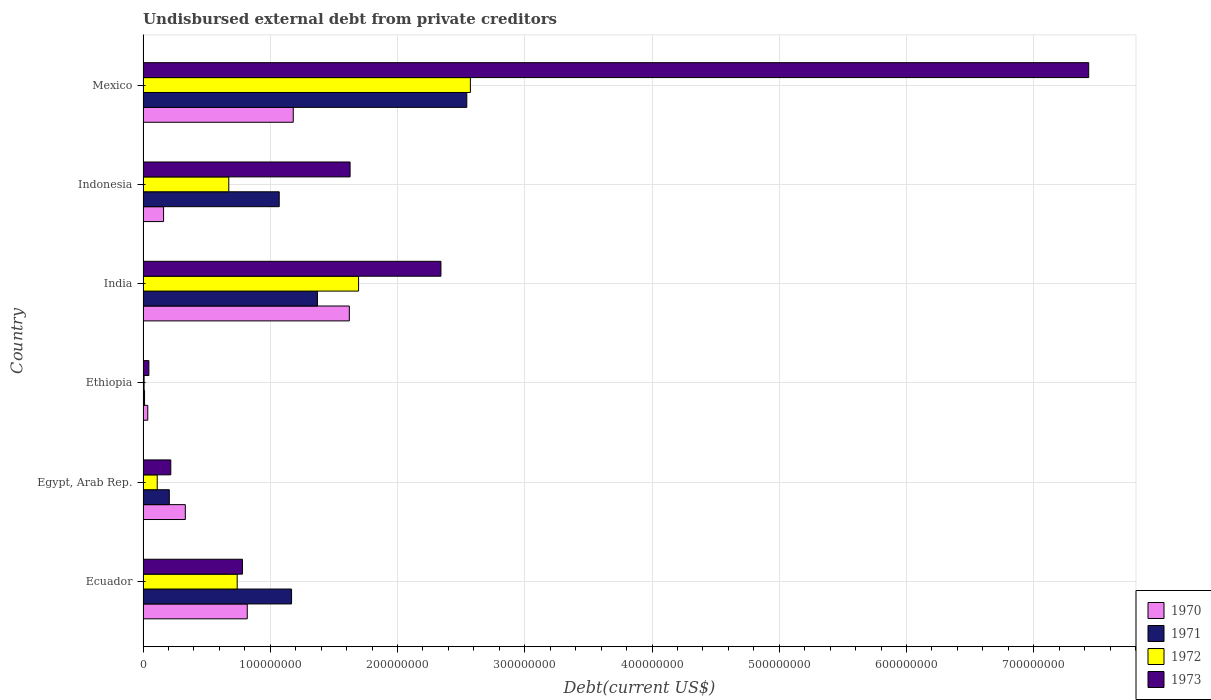How many different coloured bars are there?
Provide a succinct answer. 4. What is the label of the 4th group of bars from the top?
Provide a short and direct response. Ethiopia. In how many cases, is the number of bars for a given country not equal to the number of legend labels?
Your answer should be compact. 0. What is the total debt in 1973 in Ethiopia?
Make the answer very short. 4.57e+06. Across all countries, what is the maximum total debt in 1973?
Give a very brief answer. 7.43e+08. Across all countries, what is the minimum total debt in 1970?
Offer a very short reply. 3.70e+06. In which country was the total debt in 1973 maximum?
Ensure brevity in your answer.  Mexico. In which country was the total debt in 1970 minimum?
Offer a terse response. Ethiopia. What is the total total debt in 1972 in the graph?
Your answer should be very brief. 5.80e+08. What is the difference between the total debt in 1970 in India and that in Mexico?
Give a very brief answer. 4.41e+07. What is the difference between the total debt in 1970 in India and the total debt in 1971 in Ecuador?
Your response must be concise. 4.54e+07. What is the average total debt in 1971 per country?
Your answer should be very brief. 1.06e+08. What is the difference between the total debt in 1972 and total debt in 1973 in Ecuador?
Ensure brevity in your answer.  -4.14e+06. What is the ratio of the total debt in 1973 in India to that in Mexico?
Your answer should be compact. 0.31. Is the total debt in 1971 in India less than that in Indonesia?
Ensure brevity in your answer.  No. Is the difference between the total debt in 1972 in Ecuador and Indonesia greater than the difference between the total debt in 1973 in Ecuador and Indonesia?
Keep it short and to the point. Yes. What is the difference between the highest and the second highest total debt in 1970?
Keep it short and to the point. 4.41e+07. What is the difference between the highest and the lowest total debt in 1970?
Keep it short and to the point. 1.58e+08. Is the sum of the total debt in 1972 in Egypt, Arab Rep. and Ethiopia greater than the maximum total debt in 1973 across all countries?
Provide a short and direct response. No. What does the 1st bar from the top in Egypt, Arab Rep. represents?
Make the answer very short. 1973. Is it the case that in every country, the sum of the total debt in 1971 and total debt in 1972 is greater than the total debt in 1970?
Keep it short and to the point. No. Are all the bars in the graph horizontal?
Your response must be concise. Yes. What is the difference between two consecutive major ticks on the X-axis?
Make the answer very short. 1.00e+08. What is the title of the graph?
Your answer should be compact. Undisbursed external debt from private creditors. What is the label or title of the X-axis?
Provide a succinct answer. Debt(current US$). What is the Debt(current US$) of 1970 in Ecuador?
Your answer should be compact. 8.19e+07. What is the Debt(current US$) of 1971 in Ecuador?
Your answer should be compact. 1.17e+08. What is the Debt(current US$) in 1972 in Ecuador?
Your response must be concise. 7.40e+07. What is the Debt(current US$) of 1973 in Ecuador?
Offer a very short reply. 7.81e+07. What is the Debt(current US$) in 1970 in Egypt, Arab Rep.?
Ensure brevity in your answer.  3.32e+07. What is the Debt(current US$) in 1971 in Egypt, Arab Rep.?
Your response must be concise. 2.06e+07. What is the Debt(current US$) of 1972 in Egypt, Arab Rep.?
Your response must be concise. 1.11e+07. What is the Debt(current US$) of 1973 in Egypt, Arab Rep.?
Give a very brief answer. 2.18e+07. What is the Debt(current US$) in 1970 in Ethiopia?
Provide a succinct answer. 3.70e+06. What is the Debt(current US$) in 1971 in Ethiopia?
Your answer should be very brief. 1.16e+06. What is the Debt(current US$) of 1972 in Ethiopia?
Offer a terse response. 8.20e+05. What is the Debt(current US$) of 1973 in Ethiopia?
Your answer should be compact. 4.57e+06. What is the Debt(current US$) in 1970 in India?
Offer a terse response. 1.62e+08. What is the Debt(current US$) in 1971 in India?
Give a very brief answer. 1.37e+08. What is the Debt(current US$) in 1972 in India?
Your answer should be very brief. 1.69e+08. What is the Debt(current US$) of 1973 in India?
Keep it short and to the point. 2.34e+08. What is the Debt(current US$) of 1970 in Indonesia?
Your answer should be very brief. 1.61e+07. What is the Debt(current US$) of 1971 in Indonesia?
Provide a succinct answer. 1.07e+08. What is the Debt(current US$) of 1972 in Indonesia?
Offer a very short reply. 6.74e+07. What is the Debt(current US$) of 1973 in Indonesia?
Make the answer very short. 1.63e+08. What is the Debt(current US$) in 1970 in Mexico?
Provide a succinct answer. 1.18e+08. What is the Debt(current US$) of 1971 in Mexico?
Your response must be concise. 2.54e+08. What is the Debt(current US$) in 1972 in Mexico?
Your answer should be very brief. 2.57e+08. What is the Debt(current US$) of 1973 in Mexico?
Offer a terse response. 7.43e+08. Across all countries, what is the maximum Debt(current US$) in 1970?
Ensure brevity in your answer.  1.62e+08. Across all countries, what is the maximum Debt(current US$) in 1971?
Keep it short and to the point. 2.54e+08. Across all countries, what is the maximum Debt(current US$) in 1972?
Provide a short and direct response. 2.57e+08. Across all countries, what is the maximum Debt(current US$) of 1973?
Ensure brevity in your answer.  7.43e+08. Across all countries, what is the minimum Debt(current US$) in 1970?
Offer a terse response. 3.70e+06. Across all countries, what is the minimum Debt(current US$) in 1971?
Ensure brevity in your answer.  1.16e+06. Across all countries, what is the minimum Debt(current US$) in 1972?
Provide a succinct answer. 8.20e+05. Across all countries, what is the minimum Debt(current US$) of 1973?
Ensure brevity in your answer.  4.57e+06. What is the total Debt(current US$) of 1970 in the graph?
Provide a short and direct response. 4.15e+08. What is the total Debt(current US$) of 1971 in the graph?
Keep it short and to the point. 6.37e+08. What is the total Debt(current US$) in 1972 in the graph?
Provide a short and direct response. 5.80e+08. What is the total Debt(current US$) in 1973 in the graph?
Your response must be concise. 1.24e+09. What is the difference between the Debt(current US$) of 1970 in Ecuador and that in Egypt, Arab Rep.?
Keep it short and to the point. 4.87e+07. What is the difference between the Debt(current US$) of 1971 in Ecuador and that in Egypt, Arab Rep.?
Keep it short and to the point. 9.61e+07. What is the difference between the Debt(current US$) in 1972 in Ecuador and that in Egypt, Arab Rep.?
Provide a succinct answer. 6.28e+07. What is the difference between the Debt(current US$) of 1973 in Ecuador and that in Egypt, Arab Rep.?
Offer a terse response. 5.63e+07. What is the difference between the Debt(current US$) in 1970 in Ecuador and that in Ethiopia?
Offer a very short reply. 7.82e+07. What is the difference between the Debt(current US$) of 1971 in Ecuador and that in Ethiopia?
Keep it short and to the point. 1.16e+08. What is the difference between the Debt(current US$) of 1972 in Ecuador and that in Ethiopia?
Offer a very short reply. 7.32e+07. What is the difference between the Debt(current US$) in 1973 in Ecuador and that in Ethiopia?
Offer a terse response. 7.35e+07. What is the difference between the Debt(current US$) of 1970 in Ecuador and that in India?
Keep it short and to the point. -8.02e+07. What is the difference between the Debt(current US$) of 1971 in Ecuador and that in India?
Keep it short and to the point. -2.03e+07. What is the difference between the Debt(current US$) of 1972 in Ecuador and that in India?
Your answer should be very brief. -9.54e+07. What is the difference between the Debt(current US$) of 1973 in Ecuador and that in India?
Provide a succinct answer. -1.56e+08. What is the difference between the Debt(current US$) of 1970 in Ecuador and that in Indonesia?
Ensure brevity in your answer.  6.58e+07. What is the difference between the Debt(current US$) in 1971 in Ecuador and that in Indonesia?
Keep it short and to the point. 9.70e+06. What is the difference between the Debt(current US$) in 1972 in Ecuador and that in Indonesia?
Your answer should be compact. 6.60e+06. What is the difference between the Debt(current US$) in 1973 in Ecuador and that in Indonesia?
Your response must be concise. -8.46e+07. What is the difference between the Debt(current US$) of 1970 in Ecuador and that in Mexico?
Offer a terse response. -3.62e+07. What is the difference between the Debt(current US$) of 1971 in Ecuador and that in Mexico?
Offer a terse response. -1.38e+08. What is the difference between the Debt(current US$) in 1972 in Ecuador and that in Mexico?
Your answer should be compact. -1.83e+08. What is the difference between the Debt(current US$) in 1973 in Ecuador and that in Mexico?
Provide a succinct answer. -6.65e+08. What is the difference between the Debt(current US$) in 1970 in Egypt, Arab Rep. and that in Ethiopia?
Give a very brief answer. 2.95e+07. What is the difference between the Debt(current US$) of 1971 in Egypt, Arab Rep. and that in Ethiopia?
Ensure brevity in your answer.  1.95e+07. What is the difference between the Debt(current US$) in 1972 in Egypt, Arab Rep. and that in Ethiopia?
Provide a succinct answer. 1.03e+07. What is the difference between the Debt(current US$) in 1973 in Egypt, Arab Rep. and that in Ethiopia?
Keep it short and to the point. 1.72e+07. What is the difference between the Debt(current US$) of 1970 in Egypt, Arab Rep. and that in India?
Offer a terse response. -1.29e+08. What is the difference between the Debt(current US$) of 1971 in Egypt, Arab Rep. and that in India?
Offer a terse response. -1.16e+08. What is the difference between the Debt(current US$) in 1972 in Egypt, Arab Rep. and that in India?
Offer a terse response. -1.58e+08. What is the difference between the Debt(current US$) in 1973 in Egypt, Arab Rep. and that in India?
Ensure brevity in your answer.  -2.12e+08. What is the difference between the Debt(current US$) in 1970 in Egypt, Arab Rep. and that in Indonesia?
Ensure brevity in your answer.  1.71e+07. What is the difference between the Debt(current US$) of 1971 in Egypt, Arab Rep. and that in Indonesia?
Ensure brevity in your answer.  -8.64e+07. What is the difference between the Debt(current US$) in 1972 in Egypt, Arab Rep. and that in Indonesia?
Ensure brevity in your answer.  -5.62e+07. What is the difference between the Debt(current US$) of 1973 in Egypt, Arab Rep. and that in Indonesia?
Your response must be concise. -1.41e+08. What is the difference between the Debt(current US$) in 1970 in Egypt, Arab Rep. and that in Mexico?
Your response must be concise. -8.48e+07. What is the difference between the Debt(current US$) in 1971 in Egypt, Arab Rep. and that in Mexico?
Ensure brevity in your answer.  -2.34e+08. What is the difference between the Debt(current US$) of 1972 in Egypt, Arab Rep. and that in Mexico?
Keep it short and to the point. -2.46e+08. What is the difference between the Debt(current US$) in 1973 in Egypt, Arab Rep. and that in Mexico?
Make the answer very short. -7.21e+08. What is the difference between the Debt(current US$) of 1970 in Ethiopia and that in India?
Offer a very short reply. -1.58e+08. What is the difference between the Debt(current US$) in 1971 in Ethiopia and that in India?
Make the answer very short. -1.36e+08. What is the difference between the Debt(current US$) of 1972 in Ethiopia and that in India?
Provide a short and direct response. -1.69e+08. What is the difference between the Debt(current US$) of 1973 in Ethiopia and that in India?
Make the answer very short. -2.30e+08. What is the difference between the Debt(current US$) of 1970 in Ethiopia and that in Indonesia?
Your answer should be compact. -1.24e+07. What is the difference between the Debt(current US$) in 1971 in Ethiopia and that in Indonesia?
Your answer should be very brief. -1.06e+08. What is the difference between the Debt(current US$) in 1972 in Ethiopia and that in Indonesia?
Offer a very short reply. -6.66e+07. What is the difference between the Debt(current US$) in 1973 in Ethiopia and that in Indonesia?
Give a very brief answer. -1.58e+08. What is the difference between the Debt(current US$) of 1970 in Ethiopia and that in Mexico?
Provide a succinct answer. -1.14e+08. What is the difference between the Debt(current US$) in 1971 in Ethiopia and that in Mexico?
Ensure brevity in your answer.  -2.53e+08. What is the difference between the Debt(current US$) in 1972 in Ethiopia and that in Mexico?
Your answer should be very brief. -2.56e+08. What is the difference between the Debt(current US$) of 1973 in Ethiopia and that in Mexico?
Ensure brevity in your answer.  -7.39e+08. What is the difference between the Debt(current US$) of 1970 in India and that in Indonesia?
Your response must be concise. 1.46e+08. What is the difference between the Debt(current US$) of 1971 in India and that in Indonesia?
Your answer should be compact. 3.00e+07. What is the difference between the Debt(current US$) of 1972 in India and that in Indonesia?
Keep it short and to the point. 1.02e+08. What is the difference between the Debt(current US$) of 1973 in India and that in Indonesia?
Your answer should be very brief. 7.14e+07. What is the difference between the Debt(current US$) in 1970 in India and that in Mexico?
Offer a terse response. 4.41e+07. What is the difference between the Debt(current US$) of 1971 in India and that in Mexico?
Ensure brevity in your answer.  -1.17e+08. What is the difference between the Debt(current US$) of 1972 in India and that in Mexico?
Keep it short and to the point. -8.79e+07. What is the difference between the Debt(current US$) of 1973 in India and that in Mexico?
Keep it short and to the point. -5.09e+08. What is the difference between the Debt(current US$) in 1970 in Indonesia and that in Mexico?
Your answer should be compact. -1.02e+08. What is the difference between the Debt(current US$) in 1971 in Indonesia and that in Mexico?
Keep it short and to the point. -1.47e+08. What is the difference between the Debt(current US$) in 1972 in Indonesia and that in Mexico?
Keep it short and to the point. -1.90e+08. What is the difference between the Debt(current US$) in 1973 in Indonesia and that in Mexico?
Make the answer very short. -5.81e+08. What is the difference between the Debt(current US$) of 1970 in Ecuador and the Debt(current US$) of 1971 in Egypt, Arab Rep.?
Make the answer very short. 6.13e+07. What is the difference between the Debt(current US$) of 1970 in Ecuador and the Debt(current US$) of 1972 in Egypt, Arab Rep.?
Offer a very short reply. 7.08e+07. What is the difference between the Debt(current US$) of 1970 in Ecuador and the Debt(current US$) of 1973 in Egypt, Arab Rep.?
Your response must be concise. 6.01e+07. What is the difference between the Debt(current US$) in 1971 in Ecuador and the Debt(current US$) in 1972 in Egypt, Arab Rep.?
Keep it short and to the point. 1.06e+08. What is the difference between the Debt(current US$) in 1971 in Ecuador and the Debt(current US$) in 1973 in Egypt, Arab Rep.?
Offer a very short reply. 9.49e+07. What is the difference between the Debt(current US$) of 1972 in Ecuador and the Debt(current US$) of 1973 in Egypt, Arab Rep.?
Keep it short and to the point. 5.22e+07. What is the difference between the Debt(current US$) of 1970 in Ecuador and the Debt(current US$) of 1971 in Ethiopia?
Make the answer very short. 8.07e+07. What is the difference between the Debt(current US$) in 1970 in Ecuador and the Debt(current US$) in 1972 in Ethiopia?
Provide a short and direct response. 8.11e+07. What is the difference between the Debt(current US$) of 1970 in Ecuador and the Debt(current US$) of 1973 in Ethiopia?
Your answer should be compact. 7.73e+07. What is the difference between the Debt(current US$) in 1971 in Ecuador and the Debt(current US$) in 1972 in Ethiopia?
Keep it short and to the point. 1.16e+08. What is the difference between the Debt(current US$) of 1971 in Ecuador and the Debt(current US$) of 1973 in Ethiopia?
Provide a short and direct response. 1.12e+08. What is the difference between the Debt(current US$) in 1972 in Ecuador and the Debt(current US$) in 1973 in Ethiopia?
Your answer should be compact. 6.94e+07. What is the difference between the Debt(current US$) in 1970 in Ecuador and the Debt(current US$) in 1971 in India?
Offer a terse response. -5.52e+07. What is the difference between the Debt(current US$) in 1970 in Ecuador and the Debt(current US$) in 1972 in India?
Provide a short and direct response. -8.75e+07. What is the difference between the Debt(current US$) in 1970 in Ecuador and the Debt(current US$) in 1973 in India?
Ensure brevity in your answer.  -1.52e+08. What is the difference between the Debt(current US$) of 1971 in Ecuador and the Debt(current US$) of 1972 in India?
Ensure brevity in your answer.  -5.27e+07. What is the difference between the Debt(current US$) of 1971 in Ecuador and the Debt(current US$) of 1973 in India?
Your answer should be very brief. -1.17e+08. What is the difference between the Debt(current US$) of 1972 in Ecuador and the Debt(current US$) of 1973 in India?
Give a very brief answer. -1.60e+08. What is the difference between the Debt(current US$) of 1970 in Ecuador and the Debt(current US$) of 1971 in Indonesia?
Offer a very short reply. -2.51e+07. What is the difference between the Debt(current US$) of 1970 in Ecuador and the Debt(current US$) of 1972 in Indonesia?
Ensure brevity in your answer.  1.45e+07. What is the difference between the Debt(current US$) in 1970 in Ecuador and the Debt(current US$) in 1973 in Indonesia?
Ensure brevity in your answer.  -8.08e+07. What is the difference between the Debt(current US$) in 1971 in Ecuador and the Debt(current US$) in 1972 in Indonesia?
Offer a very short reply. 4.93e+07. What is the difference between the Debt(current US$) of 1971 in Ecuador and the Debt(current US$) of 1973 in Indonesia?
Provide a succinct answer. -4.60e+07. What is the difference between the Debt(current US$) in 1972 in Ecuador and the Debt(current US$) in 1973 in Indonesia?
Keep it short and to the point. -8.87e+07. What is the difference between the Debt(current US$) of 1970 in Ecuador and the Debt(current US$) of 1971 in Mexico?
Your answer should be very brief. -1.73e+08. What is the difference between the Debt(current US$) of 1970 in Ecuador and the Debt(current US$) of 1972 in Mexico?
Offer a terse response. -1.75e+08. What is the difference between the Debt(current US$) of 1970 in Ecuador and the Debt(current US$) of 1973 in Mexico?
Offer a very short reply. -6.61e+08. What is the difference between the Debt(current US$) in 1971 in Ecuador and the Debt(current US$) in 1972 in Mexico?
Offer a terse response. -1.41e+08. What is the difference between the Debt(current US$) in 1971 in Ecuador and the Debt(current US$) in 1973 in Mexico?
Ensure brevity in your answer.  -6.27e+08. What is the difference between the Debt(current US$) of 1972 in Ecuador and the Debt(current US$) of 1973 in Mexico?
Your response must be concise. -6.69e+08. What is the difference between the Debt(current US$) of 1970 in Egypt, Arab Rep. and the Debt(current US$) of 1971 in Ethiopia?
Your answer should be compact. 3.21e+07. What is the difference between the Debt(current US$) of 1970 in Egypt, Arab Rep. and the Debt(current US$) of 1972 in Ethiopia?
Give a very brief answer. 3.24e+07. What is the difference between the Debt(current US$) of 1970 in Egypt, Arab Rep. and the Debt(current US$) of 1973 in Ethiopia?
Your response must be concise. 2.87e+07. What is the difference between the Debt(current US$) of 1971 in Egypt, Arab Rep. and the Debt(current US$) of 1972 in Ethiopia?
Keep it short and to the point. 1.98e+07. What is the difference between the Debt(current US$) of 1971 in Egypt, Arab Rep. and the Debt(current US$) of 1973 in Ethiopia?
Give a very brief answer. 1.61e+07. What is the difference between the Debt(current US$) of 1972 in Egypt, Arab Rep. and the Debt(current US$) of 1973 in Ethiopia?
Offer a very short reply. 6.56e+06. What is the difference between the Debt(current US$) in 1970 in Egypt, Arab Rep. and the Debt(current US$) in 1971 in India?
Provide a short and direct response. -1.04e+08. What is the difference between the Debt(current US$) of 1970 in Egypt, Arab Rep. and the Debt(current US$) of 1972 in India?
Provide a succinct answer. -1.36e+08. What is the difference between the Debt(current US$) of 1970 in Egypt, Arab Rep. and the Debt(current US$) of 1973 in India?
Provide a short and direct response. -2.01e+08. What is the difference between the Debt(current US$) in 1971 in Egypt, Arab Rep. and the Debt(current US$) in 1972 in India?
Your response must be concise. -1.49e+08. What is the difference between the Debt(current US$) of 1971 in Egypt, Arab Rep. and the Debt(current US$) of 1973 in India?
Offer a very short reply. -2.13e+08. What is the difference between the Debt(current US$) in 1972 in Egypt, Arab Rep. and the Debt(current US$) in 1973 in India?
Ensure brevity in your answer.  -2.23e+08. What is the difference between the Debt(current US$) of 1970 in Egypt, Arab Rep. and the Debt(current US$) of 1971 in Indonesia?
Your response must be concise. -7.38e+07. What is the difference between the Debt(current US$) in 1970 in Egypt, Arab Rep. and the Debt(current US$) in 1972 in Indonesia?
Your answer should be very brief. -3.42e+07. What is the difference between the Debt(current US$) in 1970 in Egypt, Arab Rep. and the Debt(current US$) in 1973 in Indonesia?
Provide a short and direct response. -1.29e+08. What is the difference between the Debt(current US$) of 1971 in Egypt, Arab Rep. and the Debt(current US$) of 1972 in Indonesia?
Provide a short and direct response. -4.67e+07. What is the difference between the Debt(current US$) of 1971 in Egypt, Arab Rep. and the Debt(current US$) of 1973 in Indonesia?
Provide a short and direct response. -1.42e+08. What is the difference between the Debt(current US$) in 1972 in Egypt, Arab Rep. and the Debt(current US$) in 1973 in Indonesia?
Ensure brevity in your answer.  -1.52e+08. What is the difference between the Debt(current US$) in 1970 in Egypt, Arab Rep. and the Debt(current US$) in 1971 in Mexico?
Provide a short and direct response. -2.21e+08. What is the difference between the Debt(current US$) of 1970 in Egypt, Arab Rep. and the Debt(current US$) of 1972 in Mexico?
Your answer should be very brief. -2.24e+08. What is the difference between the Debt(current US$) in 1970 in Egypt, Arab Rep. and the Debt(current US$) in 1973 in Mexico?
Your response must be concise. -7.10e+08. What is the difference between the Debt(current US$) of 1971 in Egypt, Arab Rep. and the Debt(current US$) of 1972 in Mexico?
Your answer should be compact. -2.37e+08. What is the difference between the Debt(current US$) in 1971 in Egypt, Arab Rep. and the Debt(current US$) in 1973 in Mexico?
Offer a terse response. -7.23e+08. What is the difference between the Debt(current US$) of 1972 in Egypt, Arab Rep. and the Debt(current US$) of 1973 in Mexico?
Give a very brief answer. -7.32e+08. What is the difference between the Debt(current US$) in 1970 in Ethiopia and the Debt(current US$) in 1971 in India?
Ensure brevity in your answer.  -1.33e+08. What is the difference between the Debt(current US$) of 1970 in Ethiopia and the Debt(current US$) of 1972 in India?
Offer a very short reply. -1.66e+08. What is the difference between the Debt(current US$) in 1970 in Ethiopia and the Debt(current US$) in 1973 in India?
Offer a very short reply. -2.30e+08. What is the difference between the Debt(current US$) of 1971 in Ethiopia and the Debt(current US$) of 1972 in India?
Offer a terse response. -1.68e+08. What is the difference between the Debt(current US$) of 1971 in Ethiopia and the Debt(current US$) of 1973 in India?
Offer a terse response. -2.33e+08. What is the difference between the Debt(current US$) of 1972 in Ethiopia and the Debt(current US$) of 1973 in India?
Provide a succinct answer. -2.33e+08. What is the difference between the Debt(current US$) in 1970 in Ethiopia and the Debt(current US$) in 1971 in Indonesia?
Give a very brief answer. -1.03e+08. What is the difference between the Debt(current US$) of 1970 in Ethiopia and the Debt(current US$) of 1972 in Indonesia?
Your answer should be very brief. -6.37e+07. What is the difference between the Debt(current US$) in 1970 in Ethiopia and the Debt(current US$) in 1973 in Indonesia?
Your response must be concise. -1.59e+08. What is the difference between the Debt(current US$) in 1971 in Ethiopia and the Debt(current US$) in 1972 in Indonesia?
Keep it short and to the point. -6.62e+07. What is the difference between the Debt(current US$) of 1971 in Ethiopia and the Debt(current US$) of 1973 in Indonesia?
Provide a succinct answer. -1.62e+08. What is the difference between the Debt(current US$) in 1972 in Ethiopia and the Debt(current US$) in 1973 in Indonesia?
Ensure brevity in your answer.  -1.62e+08. What is the difference between the Debt(current US$) in 1970 in Ethiopia and the Debt(current US$) in 1971 in Mexico?
Provide a succinct answer. -2.51e+08. What is the difference between the Debt(current US$) of 1970 in Ethiopia and the Debt(current US$) of 1972 in Mexico?
Your response must be concise. -2.54e+08. What is the difference between the Debt(current US$) of 1970 in Ethiopia and the Debt(current US$) of 1973 in Mexico?
Your response must be concise. -7.40e+08. What is the difference between the Debt(current US$) in 1971 in Ethiopia and the Debt(current US$) in 1972 in Mexico?
Your answer should be compact. -2.56e+08. What is the difference between the Debt(current US$) of 1971 in Ethiopia and the Debt(current US$) of 1973 in Mexico?
Keep it short and to the point. -7.42e+08. What is the difference between the Debt(current US$) in 1972 in Ethiopia and the Debt(current US$) in 1973 in Mexico?
Your answer should be very brief. -7.42e+08. What is the difference between the Debt(current US$) in 1970 in India and the Debt(current US$) in 1971 in Indonesia?
Offer a very short reply. 5.51e+07. What is the difference between the Debt(current US$) in 1970 in India and the Debt(current US$) in 1972 in Indonesia?
Your answer should be compact. 9.47e+07. What is the difference between the Debt(current US$) in 1970 in India and the Debt(current US$) in 1973 in Indonesia?
Offer a very short reply. -5.84e+05. What is the difference between the Debt(current US$) in 1971 in India and the Debt(current US$) in 1972 in Indonesia?
Offer a very short reply. 6.97e+07. What is the difference between the Debt(current US$) in 1971 in India and the Debt(current US$) in 1973 in Indonesia?
Offer a terse response. -2.56e+07. What is the difference between the Debt(current US$) of 1972 in India and the Debt(current US$) of 1973 in Indonesia?
Your answer should be compact. 6.68e+06. What is the difference between the Debt(current US$) of 1970 in India and the Debt(current US$) of 1971 in Mexico?
Your answer should be compact. -9.23e+07. What is the difference between the Debt(current US$) in 1970 in India and the Debt(current US$) in 1972 in Mexico?
Offer a terse response. -9.51e+07. What is the difference between the Debt(current US$) in 1970 in India and the Debt(current US$) in 1973 in Mexico?
Make the answer very short. -5.81e+08. What is the difference between the Debt(current US$) of 1971 in India and the Debt(current US$) of 1972 in Mexico?
Your answer should be compact. -1.20e+08. What is the difference between the Debt(current US$) in 1971 in India and the Debt(current US$) in 1973 in Mexico?
Keep it short and to the point. -6.06e+08. What is the difference between the Debt(current US$) of 1972 in India and the Debt(current US$) of 1973 in Mexico?
Give a very brief answer. -5.74e+08. What is the difference between the Debt(current US$) in 1970 in Indonesia and the Debt(current US$) in 1971 in Mexico?
Provide a succinct answer. -2.38e+08. What is the difference between the Debt(current US$) of 1970 in Indonesia and the Debt(current US$) of 1972 in Mexico?
Give a very brief answer. -2.41e+08. What is the difference between the Debt(current US$) of 1970 in Indonesia and the Debt(current US$) of 1973 in Mexico?
Your answer should be compact. -7.27e+08. What is the difference between the Debt(current US$) of 1971 in Indonesia and the Debt(current US$) of 1972 in Mexico?
Your answer should be very brief. -1.50e+08. What is the difference between the Debt(current US$) in 1971 in Indonesia and the Debt(current US$) in 1973 in Mexico?
Your answer should be very brief. -6.36e+08. What is the difference between the Debt(current US$) in 1972 in Indonesia and the Debt(current US$) in 1973 in Mexico?
Make the answer very short. -6.76e+08. What is the average Debt(current US$) of 1970 per country?
Provide a short and direct response. 6.92e+07. What is the average Debt(current US$) of 1971 per country?
Keep it short and to the point. 1.06e+08. What is the average Debt(current US$) of 1972 per country?
Your answer should be very brief. 9.67e+07. What is the average Debt(current US$) in 1973 per country?
Offer a terse response. 2.07e+08. What is the difference between the Debt(current US$) of 1970 and Debt(current US$) of 1971 in Ecuador?
Your answer should be compact. -3.48e+07. What is the difference between the Debt(current US$) in 1970 and Debt(current US$) in 1972 in Ecuador?
Your answer should be very brief. 7.92e+06. What is the difference between the Debt(current US$) of 1970 and Debt(current US$) of 1973 in Ecuador?
Your response must be concise. 3.78e+06. What is the difference between the Debt(current US$) in 1971 and Debt(current US$) in 1972 in Ecuador?
Your answer should be very brief. 4.27e+07. What is the difference between the Debt(current US$) of 1971 and Debt(current US$) of 1973 in Ecuador?
Your answer should be very brief. 3.86e+07. What is the difference between the Debt(current US$) in 1972 and Debt(current US$) in 1973 in Ecuador?
Offer a very short reply. -4.14e+06. What is the difference between the Debt(current US$) of 1970 and Debt(current US$) of 1971 in Egypt, Arab Rep.?
Make the answer very short. 1.26e+07. What is the difference between the Debt(current US$) in 1970 and Debt(current US$) in 1972 in Egypt, Arab Rep.?
Offer a very short reply. 2.21e+07. What is the difference between the Debt(current US$) of 1970 and Debt(current US$) of 1973 in Egypt, Arab Rep.?
Provide a succinct answer. 1.14e+07. What is the difference between the Debt(current US$) of 1971 and Debt(current US$) of 1972 in Egypt, Arab Rep.?
Keep it short and to the point. 9.50e+06. What is the difference between the Debt(current US$) of 1971 and Debt(current US$) of 1973 in Egypt, Arab Rep.?
Make the answer very short. -1.17e+06. What is the difference between the Debt(current US$) in 1972 and Debt(current US$) in 1973 in Egypt, Arab Rep.?
Your answer should be very brief. -1.07e+07. What is the difference between the Debt(current US$) of 1970 and Debt(current US$) of 1971 in Ethiopia?
Your answer should be very brief. 2.53e+06. What is the difference between the Debt(current US$) of 1970 and Debt(current US$) of 1972 in Ethiopia?
Offer a very short reply. 2.88e+06. What is the difference between the Debt(current US$) in 1970 and Debt(current US$) in 1973 in Ethiopia?
Keep it short and to the point. -8.70e+05. What is the difference between the Debt(current US$) of 1971 and Debt(current US$) of 1972 in Ethiopia?
Provide a short and direct response. 3.45e+05. What is the difference between the Debt(current US$) of 1971 and Debt(current US$) of 1973 in Ethiopia?
Make the answer very short. -3.40e+06. What is the difference between the Debt(current US$) in 1972 and Debt(current US$) in 1973 in Ethiopia?
Offer a very short reply. -3.75e+06. What is the difference between the Debt(current US$) in 1970 and Debt(current US$) in 1971 in India?
Keep it short and to the point. 2.51e+07. What is the difference between the Debt(current US$) of 1970 and Debt(current US$) of 1972 in India?
Offer a very short reply. -7.26e+06. What is the difference between the Debt(current US$) in 1970 and Debt(current US$) in 1973 in India?
Provide a succinct answer. -7.20e+07. What is the difference between the Debt(current US$) in 1971 and Debt(current US$) in 1972 in India?
Your answer should be compact. -3.23e+07. What is the difference between the Debt(current US$) in 1971 and Debt(current US$) in 1973 in India?
Your answer should be very brief. -9.70e+07. What is the difference between the Debt(current US$) of 1972 and Debt(current US$) of 1973 in India?
Your answer should be compact. -6.47e+07. What is the difference between the Debt(current US$) of 1970 and Debt(current US$) of 1971 in Indonesia?
Ensure brevity in your answer.  -9.09e+07. What is the difference between the Debt(current US$) of 1970 and Debt(current US$) of 1972 in Indonesia?
Provide a succinct answer. -5.12e+07. What is the difference between the Debt(current US$) in 1970 and Debt(current US$) in 1973 in Indonesia?
Ensure brevity in your answer.  -1.47e+08. What is the difference between the Debt(current US$) of 1971 and Debt(current US$) of 1972 in Indonesia?
Your answer should be very brief. 3.96e+07. What is the difference between the Debt(current US$) of 1971 and Debt(current US$) of 1973 in Indonesia?
Offer a terse response. -5.57e+07. What is the difference between the Debt(current US$) in 1972 and Debt(current US$) in 1973 in Indonesia?
Give a very brief answer. -9.53e+07. What is the difference between the Debt(current US$) of 1970 and Debt(current US$) of 1971 in Mexico?
Offer a very short reply. -1.36e+08. What is the difference between the Debt(current US$) in 1970 and Debt(current US$) in 1972 in Mexico?
Offer a terse response. -1.39e+08. What is the difference between the Debt(current US$) of 1970 and Debt(current US$) of 1973 in Mexico?
Offer a very short reply. -6.25e+08. What is the difference between the Debt(current US$) in 1971 and Debt(current US$) in 1972 in Mexico?
Keep it short and to the point. -2.84e+06. What is the difference between the Debt(current US$) in 1971 and Debt(current US$) in 1973 in Mexico?
Your answer should be very brief. -4.89e+08. What is the difference between the Debt(current US$) of 1972 and Debt(current US$) of 1973 in Mexico?
Provide a succinct answer. -4.86e+08. What is the ratio of the Debt(current US$) in 1970 in Ecuador to that in Egypt, Arab Rep.?
Ensure brevity in your answer.  2.47. What is the ratio of the Debt(current US$) in 1971 in Ecuador to that in Egypt, Arab Rep.?
Your answer should be very brief. 5.66. What is the ratio of the Debt(current US$) of 1972 in Ecuador to that in Egypt, Arab Rep.?
Offer a terse response. 6.65. What is the ratio of the Debt(current US$) in 1973 in Ecuador to that in Egypt, Arab Rep.?
Make the answer very short. 3.58. What is the ratio of the Debt(current US$) in 1970 in Ecuador to that in Ethiopia?
Offer a very short reply. 22.15. What is the ratio of the Debt(current US$) of 1971 in Ecuador to that in Ethiopia?
Keep it short and to the point. 100.19. What is the ratio of the Debt(current US$) in 1972 in Ecuador to that in Ethiopia?
Offer a terse response. 90.21. What is the ratio of the Debt(current US$) of 1973 in Ecuador to that in Ethiopia?
Your answer should be very brief. 17.1. What is the ratio of the Debt(current US$) of 1970 in Ecuador to that in India?
Offer a terse response. 0.51. What is the ratio of the Debt(current US$) in 1971 in Ecuador to that in India?
Your answer should be very brief. 0.85. What is the ratio of the Debt(current US$) of 1972 in Ecuador to that in India?
Provide a short and direct response. 0.44. What is the ratio of the Debt(current US$) in 1973 in Ecuador to that in India?
Provide a short and direct response. 0.33. What is the ratio of the Debt(current US$) in 1970 in Ecuador to that in Indonesia?
Provide a succinct answer. 5.08. What is the ratio of the Debt(current US$) of 1971 in Ecuador to that in Indonesia?
Your response must be concise. 1.09. What is the ratio of the Debt(current US$) in 1972 in Ecuador to that in Indonesia?
Ensure brevity in your answer.  1.1. What is the ratio of the Debt(current US$) of 1973 in Ecuador to that in Indonesia?
Offer a very short reply. 0.48. What is the ratio of the Debt(current US$) of 1970 in Ecuador to that in Mexico?
Provide a succinct answer. 0.69. What is the ratio of the Debt(current US$) in 1971 in Ecuador to that in Mexico?
Ensure brevity in your answer.  0.46. What is the ratio of the Debt(current US$) of 1972 in Ecuador to that in Mexico?
Offer a very short reply. 0.29. What is the ratio of the Debt(current US$) of 1973 in Ecuador to that in Mexico?
Your answer should be compact. 0.11. What is the ratio of the Debt(current US$) of 1970 in Egypt, Arab Rep. to that in Ethiopia?
Ensure brevity in your answer.  8.99. What is the ratio of the Debt(current US$) in 1971 in Egypt, Arab Rep. to that in Ethiopia?
Provide a succinct answer. 17.71. What is the ratio of the Debt(current US$) in 1972 in Egypt, Arab Rep. to that in Ethiopia?
Ensure brevity in your answer.  13.57. What is the ratio of the Debt(current US$) of 1973 in Egypt, Arab Rep. to that in Ethiopia?
Your response must be concise. 4.77. What is the ratio of the Debt(current US$) of 1970 in Egypt, Arab Rep. to that in India?
Your answer should be very brief. 0.2. What is the ratio of the Debt(current US$) of 1971 in Egypt, Arab Rep. to that in India?
Offer a very short reply. 0.15. What is the ratio of the Debt(current US$) of 1972 in Egypt, Arab Rep. to that in India?
Your response must be concise. 0.07. What is the ratio of the Debt(current US$) in 1973 in Egypt, Arab Rep. to that in India?
Keep it short and to the point. 0.09. What is the ratio of the Debt(current US$) in 1970 in Egypt, Arab Rep. to that in Indonesia?
Provide a short and direct response. 2.06. What is the ratio of the Debt(current US$) in 1971 in Egypt, Arab Rep. to that in Indonesia?
Your response must be concise. 0.19. What is the ratio of the Debt(current US$) in 1972 in Egypt, Arab Rep. to that in Indonesia?
Keep it short and to the point. 0.17. What is the ratio of the Debt(current US$) in 1973 in Egypt, Arab Rep. to that in Indonesia?
Ensure brevity in your answer.  0.13. What is the ratio of the Debt(current US$) in 1970 in Egypt, Arab Rep. to that in Mexico?
Your answer should be very brief. 0.28. What is the ratio of the Debt(current US$) of 1971 in Egypt, Arab Rep. to that in Mexico?
Your answer should be compact. 0.08. What is the ratio of the Debt(current US$) of 1972 in Egypt, Arab Rep. to that in Mexico?
Your response must be concise. 0.04. What is the ratio of the Debt(current US$) of 1973 in Egypt, Arab Rep. to that in Mexico?
Offer a terse response. 0.03. What is the ratio of the Debt(current US$) in 1970 in Ethiopia to that in India?
Offer a very short reply. 0.02. What is the ratio of the Debt(current US$) of 1971 in Ethiopia to that in India?
Offer a terse response. 0.01. What is the ratio of the Debt(current US$) of 1972 in Ethiopia to that in India?
Make the answer very short. 0. What is the ratio of the Debt(current US$) of 1973 in Ethiopia to that in India?
Provide a short and direct response. 0.02. What is the ratio of the Debt(current US$) of 1970 in Ethiopia to that in Indonesia?
Your response must be concise. 0.23. What is the ratio of the Debt(current US$) of 1971 in Ethiopia to that in Indonesia?
Offer a very short reply. 0.01. What is the ratio of the Debt(current US$) of 1972 in Ethiopia to that in Indonesia?
Your answer should be compact. 0.01. What is the ratio of the Debt(current US$) in 1973 in Ethiopia to that in Indonesia?
Provide a succinct answer. 0.03. What is the ratio of the Debt(current US$) of 1970 in Ethiopia to that in Mexico?
Offer a very short reply. 0.03. What is the ratio of the Debt(current US$) in 1971 in Ethiopia to that in Mexico?
Ensure brevity in your answer.  0. What is the ratio of the Debt(current US$) of 1972 in Ethiopia to that in Mexico?
Provide a short and direct response. 0. What is the ratio of the Debt(current US$) in 1973 in Ethiopia to that in Mexico?
Make the answer very short. 0.01. What is the ratio of the Debt(current US$) in 1970 in India to that in Indonesia?
Give a very brief answer. 10.05. What is the ratio of the Debt(current US$) of 1971 in India to that in Indonesia?
Make the answer very short. 1.28. What is the ratio of the Debt(current US$) of 1972 in India to that in Indonesia?
Ensure brevity in your answer.  2.51. What is the ratio of the Debt(current US$) of 1973 in India to that in Indonesia?
Keep it short and to the point. 1.44. What is the ratio of the Debt(current US$) of 1970 in India to that in Mexico?
Provide a short and direct response. 1.37. What is the ratio of the Debt(current US$) in 1971 in India to that in Mexico?
Make the answer very short. 0.54. What is the ratio of the Debt(current US$) of 1972 in India to that in Mexico?
Your response must be concise. 0.66. What is the ratio of the Debt(current US$) of 1973 in India to that in Mexico?
Give a very brief answer. 0.32. What is the ratio of the Debt(current US$) of 1970 in Indonesia to that in Mexico?
Ensure brevity in your answer.  0.14. What is the ratio of the Debt(current US$) of 1971 in Indonesia to that in Mexico?
Offer a terse response. 0.42. What is the ratio of the Debt(current US$) in 1972 in Indonesia to that in Mexico?
Your answer should be compact. 0.26. What is the ratio of the Debt(current US$) of 1973 in Indonesia to that in Mexico?
Provide a succinct answer. 0.22. What is the difference between the highest and the second highest Debt(current US$) of 1970?
Your response must be concise. 4.41e+07. What is the difference between the highest and the second highest Debt(current US$) in 1971?
Give a very brief answer. 1.17e+08. What is the difference between the highest and the second highest Debt(current US$) in 1972?
Give a very brief answer. 8.79e+07. What is the difference between the highest and the second highest Debt(current US$) of 1973?
Keep it short and to the point. 5.09e+08. What is the difference between the highest and the lowest Debt(current US$) in 1970?
Give a very brief answer. 1.58e+08. What is the difference between the highest and the lowest Debt(current US$) of 1971?
Provide a short and direct response. 2.53e+08. What is the difference between the highest and the lowest Debt(current US$) of 1972?
Give a very brief answer. 2.56e+08. What is the difference between the highest and the lowest Debt(current US$) in 1973?
Your answer should be very brief. 7.39e+08. 